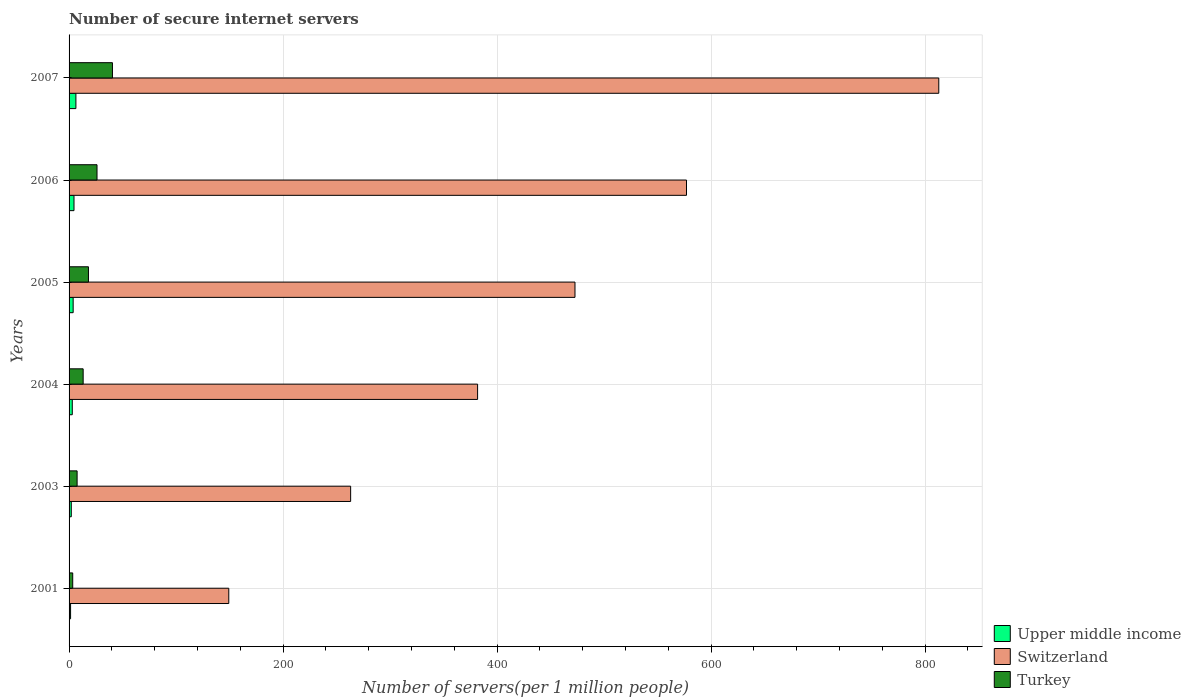How many different coloured bars are there?
Make the answer very short. 3. Are the number of bars per tick equal to the number of legend labels?
Your answer should be compact. Yes. What is the label of the 5th group of bars from the top?
Provide a short and direct response. 2003. In how many cases, is the number of bars for a given year not equal to the number of legend labels?
Provide a short and direct response. 0. What is the number of secure internet servers in Switzerland in 2007?
Offer a terse response. 812.73. Across all years, what is the maximum number of secure internet servers in Turkey?
Ensure brevity in your answer.  40.54. Across all years, what is the minimum number of secure internet servers in Switzerland?
Keep it short and to the point. 149.24. What is the total number of secure internet servers in Upper middle income in the graph?
Your answer should be compact. 21.26. What is the difference between the number of secure internet servers in Switzerland in 2005 and that in 2007?
Make the answer very short. -339.96. What is the difference between the number of secure internet servers in Switzerland in 2004 and the number of secure internet servers in Turkey in 2007?
Provide a succinct answer. 341.21. What is the average number of secure internet servers in Upper middle income per year?
Provide a succinct answer. 3.54. In the year 2006, what is the difference between the number of secure internet servers in Turkey and number of secure internet servers in Switzerland?
Offer a very short reply. -550.86. What is the ratio of the number of secure internet servers in Turkey in 2006 to that in 2007?
Your answer should be very brief. 0.64. What is the difference between the highest and the second highest number of secure internet servers in Turkey?
Provide a short and direct response. 14.43. What is the difference between the highest and the lowest number of secure internet servers in Upper middle income?
Your response must be concise. 4.97. What does the 3rd bar from the top in 2005 represents?
Offer a very short reply. Upper middle income. What does the 3rd bar from the bottom in 2005 represents?
Ensure brevity in your answer.  Turkey. How many bars are there?
Provide a succinct answer. 18. What is the difference between two consecutive major ticks on the X-axis?
Ensure brevity in your answer.  200. Are the values on the major ticks of X-axis written in scientific E-notation?
Keep it short and to the point. No. Does the graph contain grids?
Offer a very short reply. Yes. Where does the legend appear in the graph?
Ensure brevity in your answer.  Bottom right. What is the title of the graph?
Keep it short and to the point. Number of secure internet servers. What is the label or title of the X-axis?
Offer a very short reply. Number of servers(per 1 million people). What is the label or title of the Y-axis?
Provide a short and direct response. Years. What is the Number of servers(per 1 million people) of Upper middle income in 2001?
Your answer should be very brief. 1.41. What is the Number of servers(per 1 million people) of Switzerland in 2001?
Provide a succinct answer. 149.24. What is the Number of servers(per 1 million people) in Turkey in 2001?
Keep it short and to the point. 3.41. What is the Number of servers(per 1 million people) of Upper middle income in 2003?
Give a very brief answer. 2.06. What is the Number of servers(per 1 million people) in Switzerland in 2003?
Give a very brief answer. 263.11. What is the Number of servers(per 1 million people) of Turkey in 2003?
Offer a terse response. 7.51. What is the Number of servers(per 1 million people) of Upper middle income in 2004?
Your answer should be compact. 3. What is the Number of servers(per 1 million people) in Switzerland in 2004?
Give a very brief answer. 381.75. What is the Number of servers(per 1 million people) in Turkey in 2004?
Offer a terse response. 13.17. What is the Number of servers(per 1 million people) in Upper middle income in 2005?
Offer a very short reply. 3.82. What is the Number of servers(per 1 million people) in Switzerland in 2005?
Your answer should be compact. 472.76. What is the Number of servers(per 1 million people) of Turkey in 2005?
Your answer should be very brief. 18.11. What is the Number of servers(per 1 million people) in Upper middle income in 2006?
Ensure brevity in your answer.  4.6. What is the Number of servers(per 1 million people) in Switzerland in 2006?
Your answer should be compact. 576.97. What is the Number of servers(per 1 million people) of Turkey in 2006?
Make the answer very short. 26.11. What is the Number of servers(per 1 million people) in Upper middle income in 2007?
Provide a short and direct response. 6.38. What is the Number of servers(per 1 million people) of Switzerland in 2007?
Provide a succinct answer. 812.73. What is the Number of servers(per 1 million people) in Turkey in 2007?
Offer a very short reply. 40.54. Across all years, what is the maximum Number of servers(per 1 million people) of Upper middle income?
Offer a terse response. 6.38. Across all years, what is the maximum Number of servers(per 1 million people) of Switzerland?
Your response must be concise. 812.73. Across all years, what is the maximum Number of servers(per 1 million people) in Turkey?
Offer a terse response. 40.54. Across all years, what is the minimum Number of servers(per 1 million people) in Upper middle income?
Give a very brief answer. 1.41. Across all years, what is the minimum Number of servers(per 1 million people) in Switzerland?
Offer a very short reply. 149.24. Across all years, what is the minimum Number of servers(per 1 million people) in Turkey?
Your response must be concise. 3.41. What is the total Number of servers(per 1 million people) in Upper middle income in the graph?
Provide a short and direct response. 21.26. What is the total Number of servers(per 1 million people) in Switzerland in the graph?
Provide a succinct answer. 2656.57. What is the total Number of servers(per 1 million people) in Turkey in the graph?
Keep it short and to the point. 108.85. What is the difference between the Number of servers(per 1 million people) of Upper middle income in 2001 and that in 2003?
Make the answer very short. -0.65. What is the difference between the Number of servers(per 1 million people) of Switzerland in 2001 and that in 2003?
Your answer should be very brief. -113.87. What is the difference between the Number of servers(per 1 million people) in Turkey in 2001 and that in 2003?
Keep it short and to the point. -4.1. What is the difference between the Number of servers(per 1 million people) of Upper middle income in 2001 and that in 2004?
Make the answer very short. -1.59. What is the difference between the Number of servers(per 1 million people) in Switzerland in 2001 and that in 2004?
Your answer should be very brief. -232.51. What is the difference between the Number of servers(per 1 million people) in Turkey in 2001 and that in 2004?
Ensure brevity in your answer.  -9.76. What is the difference between the Number of servers(per 1 million people) of Upper middle income in 2001 and that in 2005?
Offer a terse response. -2.41. What is the difference between the Number of servers(per 1 million people) of Switzerland in 2001 and that in 2005?
Offer a terse response. -323.52. What is the difference between the Number of servers(per 1 million people) of Turkey in 2001 and that in 2005?
Your answer should be compact. -14.7. What is the difference between the Number of servers(per 1 million people) of Upper middle income in 2001 and that in 2006?
Your answer should be very brief. -3.19. What is the difference between the Number of servers(per 1 million people) in Switzerland in 2001 and that in 2006?
Give a very brief answer. -427.73. What is the difference between the Number of servers(per 1 million people) of Turkey in 2001 and that in 2006?
Your answer should be very brief. -22.7. What is the difference between the Number of servers(per 1 million people) of Upper middle income in 2001 and that in 2007?
Offer a very short reply. -4.97. What is the difference between the Number of servers(per 1 million people) of Switzerland in 2001 and that in 2007?
Your answer should be very brief. -663.49. What is the difference between the Number of servers(per 1 million people) of Turkey in 2001 and that in 2007?
Your response must be concise. -37.13. What is the difference between the Number of servers(per 1 million people) of Upper middle income in 2003 and that in 2004?
Give a very brief answer. -0.94. What is the difference between the Number of servers(per 1 million people) in Switzerland in 2003 and that in 2004?
Provide a short and direct response. -118.64. What is the difference between the Number of servers(per 1 million people) of Turkey in 2003 and that in 2004?
Your response must be concise. -5.66. What is the difference between the Number of servers(per 1 million people) in Upper middle income in 2003 and that in 2005?
Offer a terse response. -1.75. What is the difference between the Number of servers(per 1 million people) in Switzerland in 2003 and that in 2005?
Keep it short and to the point. -209.65. What is the difference between the Number of servers(per 1 million people) in Turkey in 2003 and that in 2005?
Your answer should be very brief. -10.6. What is the difference between the Number of servers(per 1 million people) in Upper middle income in 2003 and that in 2006?
Your response must be concise. -2.54. What is the difference between the Number of servers(per 1 million people) of Switzerland in 2003 and that in 2006?
Give a very brief answer. -313.85. What is the difference between the Number of servers(per 1 million people) of Turkey in 2003 and that in 2006?
Offer a very short reply. -18.6. What is the difference between the Number of servers(per 1 million people) of Upper middle income in 2003 and that in 2007?
Your response must be concise. -4.32. What is the difference between the Number of servers(per 1 million people) of Switzerland in 2003 and that in 2007?
Offer a very short reply. -549.61. What is the difference between the Number of servers(per 1 million people) in Turkey in 2003 and that in 2007?
Make the answer very short. -33.03. What is the difference between the Number of servers(per 1 million people) of Upper middle income in 2004 and that in 2005?
Ensure brevity in your answer.  -0.82. What is the difference between the Number of servers(per 1 million people) in Switzerland in 2004 and that in 2005?
Offer a very short reply. -91.01. What is the difference between the Number of servers(per 1 million people) of Turkey in 2004 and that in 2005?
Provide a succinct answer. -4.94. What is the difference between the Number of servers(per 1 million people) of Upper middle income in 2004 and that in 2006?
Make the answer very short. -1.6. What is the difference between the Number of servers(per 1 million people) of Switzerland in 2004 and that in 2006?
Provide a short and direct response. -195.22. What is the difference between the Number of servers(per 1 million people) in Turkey in 2004 and that in 2006?
Give a very brief answer. -12.94. What is the difference between the Number of servers(per 1 million people) of Upper middle income in 2004 and that in 2007?
Ensure brevity in your answer.  -3.38. What is the difference between the Number of servers(per 1 million people) of Switzerland in 2004 and that in 2007?
Provide a short and direct response. -430.98. What is the difference between the Number of servers(per 1 million people) of Turkey in 2004 and that in 2007?
Provide a succinct answer. -27.37. What is the difference between the Number of servers(per 1 million people) in Upper middle income in 2005 and that in 2006?
Offer a terse response. -0.78. What is the difference between the Number of servers(per 1 million people) of Switzerland in 2005 and that in 2006?
Offer a terse response. -104.21. What is the difference between the Number of servers(per 1 million people) in Turkey in 2005 and that in 2006?
Provide a short and direct response. -8. What is the difference between the Number of servers(per 1 million people) in Upper middle income in 2005 and that in 2007?
Make the answer very short. -2.57. What is the difference between the Number of servers(per 1 million people) of Switzerland in 2005 and that in 2007?
Your response must be concise. -339.96. What is the difference between the Number of servers(per 1 million people) of Turkey in 2005 and that in 2007?
Give a very brief answer. -22.43. What is the difference between the Number of servers(per 1 million people) of Upper middle income in 2006 and that in 2007?
Make the answer very short. -1.78. What is the difference between the Number of servers(per 1 million people) of Switzerland in 2006 and that in 2007?
Make the answer very short. -235.76. What is the difference between the Number of servers(per 1 million people) of Turkey in 2006 and that in 2007?
Provide a short and direct response. -14.43. What is the difference between the Number of servers(per 1 million people) of Upper middle income in 2001 and the Number of servers(per 1 million people) of Switzerland in 2003?
Your answer should be compact. -261.71. What is the difference between the Number of servers(per 1 million people) in Upper middle income in 2001 and the Number of servers(per 1 million people) in Turkey in 2003?
Provide a succinct answer. -6.1. What is the difference between the Number of servers(per 1 million people) in Switzerland in 2001 and the Number of servers(per 1 million people) in Turkey in 2003?
Ensure brevity in your answer.  141.73. What is the difference between the Number of servers(per 1 million people) in Upper middle income in 2001 and the Number of servers(per 1 million people) in Switzerland in 2004?
Offer a terse response. -380.34. What is the difference between the Number of servers(per 1 million people) of Upper middle income in 2001 and the Number of servers(per 1 million people) of Turkey in 2004?
Make the answer very short. -11.76. What is the difference between the Number of servers(per 1 million people) of Switzerland in 2001 and the Number of servers(per 1 million people) of Turkey in 2004?
Your answer should be very brief. 136.07. What is the difference between the Number of servers(per 1 million people) of Upper middle income in 2001 and the Number of servers(per 1 million people) of Switzerland in 2005?
Your answer should be compact. -471.35. What is the difference between the Number of servers(per 1 million people) of Upper middle income in 2001 and the Number of servers(per 1 million people) of Turkey in 2005?
Give a very brief answer. -16.7. What is the difference between the Number of servers(per 1 million people) in Switzerland in 2001 and the Number of servers(per 1 million people) in Turkey in 2005?
Offer a terse response. 131.13. What is the difference between the Number of servers(per 1 million people) of Upper middle income in 2001 and the Number of servers(per 1 million people) of Switzerland in 2006?
Your answer should be very brief. -575.56. What is the difference between the Number of servers(per 1 million people) in Upper middle income in 2001 and the Number of servers(per 1 million people) in Turkey in 2006?
Provide a short and direct response. -24.7. What is the difference between the Number of servers(per 1 million people) of Switzerland in 2001 and the Number of servers(per 1 million people) of Turkey in 2006?
Your answer should be compact. 123.13. What is the difference between the Number of servers(per 1 million people) in Upper middle income in 2001 and the Number of servers(per 1 million people) in Switzerland in 2007?
Give a very brief answer. -811.32. What is the difference between the Number of servers(per 1 million people) of Upper middle income in 2001 and the Number of servers(per 1 million people) of Turkey in 2007?
Keep it short and to the point. -39.13. What is the difference between the Number of servers(per 1 million people) in Switzerland in 2001 and the Number of servers(per 1 million people) in Turkey in 2007?
Provide a succinct answer. 108.7. What is the difference between the Number of servers(per 1 million people) of Upper middle income in 2003 and the Number of servers(per 1 million people) of Switzerland in 2004?
Make the answer very short. -379.69. What is the difference between the Number of servers(per 1 million people) in Upper middle income in 2003 and the Number of servers(per 1 million people) in Turkey in 2004?
Your answer should be very brief. -11.11. What is the difference between the Number of servers(per 1 million people) in Switzerland in 2003 and the Number of servers(per 1 million people) in Turkey in 2004?
Your answer should be very brief. 249.95. What is the difference between the Number of servers(per 1 million people) in Upper middle income in 2003 and the Number of servers(per 1 million people) in Switzerland in 2005?
Give a very brief answer. -470.7. What is the difference between the Number of servers(per 1 million people) in Upper middle income in 2003 and the Number of servers(per 1 million people) in Turkey in 2005?
Give a very brief answer. -16.05. What is the difference between the Number of servers(per 1 million people) of Switzerland in 2003 and the Number of servers(per 1 million people) of Turkey in 2005?
Keep it short and to the point. 245. What is the difference between the Number of servers(per 1 million people) of Upper middle income in 2003 and the Number of servers(per 1 million people) of Switzerland in 2006?
Make the answer very short. -574.91. What is the difference between the Number of servers(per 1 million people) in Upper middle income in 2003 and the Number of servers(per 1 million people) in Turkey in 2006?
Your answer should be compact. -24.05. What is the difference between the Number of servers(per 1 million people) of Switzerland in 2003 and the Number of servers(per 1 million people) of Turkey in 2006?
Give a very brief answer. 237. What is the difference between the Number of servers(per 1 million people) in Upper middle income in 2003 and the Number of servers(per 1 million people) in Switzerland in 2007?
Provide a succinct answer. -810.67. What is the difference between the Number of servers(per 1 million people) of Upper middle income in 2003 and the Number of servers(per 1 million people) of Turkey in 2007?
Your answer should be compact. -38.48. What is the difference between the Number of servers(per 1 million people) of Switzerland in 2003 and the Number of servers(per 1 million people) of Turkey in 2007?
Offer a very short reply. 222.58. What is the difference between the Number of servers(per 1 million people) in Upper middle income in 2004 and the Number of servers(per 1 million people) in Switzerland in 2005?
Ensure brevity in your answer.  -469.77. What is the difference between the Number of servers(per 1 million people) of Upper middle income in 2004 and the Number of servers(per 1 million people) of Turkey in 2005?
Offer a terse response. -15.11. What is the difference between the Number of servers(per 1 million people) in Switzerland in 2004 and the Number of servers(per 1 million people) in Turkey in 2005?
Your response must be concise. 363.64. What is the difference between the Number of servers(per 1 million people) in Upper middle income in 2004 and the Number of servers(per 1 million people) in Switzerland in 2006?
Provide a succinct answer. -573.97. What is the difference between the Number of servers(per 1 million people) in Upper middle income in 2004 and the Number of servers(per 1 million people) in Turkey in 2006?
Give a very brief answer. -23.12. What is the difference between the Number of servers(per 1 million people) of Switzerland in 2004 and the Number of servers(per 1 million people) of Turkey in 2006?
Provide a short and direct response. 355.64. What is the difference between the Number of servers(per 1 million people) of Upper middle income in 2004 and the Number of servers(per 1 million people) of Switzerland in 2007?
Your response must be concise. -809.73. What is the difference between the Number of servers(per 1 million people) in Upper middle income in 2004 and the Number of servers(per 1 million people) in Turkey in 2007?
Keep it short and to the point. -37.54. What is the difference between the Number of servers(per 1 million people) in Switzerland in 2004 and the Number of servers(per 1 million people) in Turkey in 2007?
Keep it short and to the point. 341.21. What is the difference between the Number of servers(per 1 million people) in Upper middle income in 2005 and the Number of servers(per 1 million people) in Switzerland in 2006?
Ensure brevity in your answer.  -573.15. What is the difference between the Number of servers(per 1 million people) of Upper middle income in 2005 and the Number of servers(per 1 million people) of Turkey in 2006?
Your answer should be very brief. -22.3. What is the difference between the Number of servers(per 1 million people) of Switzerland in 2005 and the Number of servers(per 1 million people) of Turkey in 2006?
Your response must be concise. 446.65. What is the difference between the Number of servers(per 1 million people) in Upper middle income in 2005 and the Number of servers(per 1 million people) in Switzerland in 2007?
Provide a succinct answer. -808.91. What is the difference between the Number of servers(per 1 million people) in Upper middle income in 2005 and the Number of servers(per 1 million people) in Turkey in 2007?
Keep it short and to the point. -36.72. What is the difference between the Number of servers(per 1 million people) in Switzerland in 2005 and the Number of servers(per 1 million people) in Turkey in 2007?
Offer a terse response. 432.23. What is the difference between the Number of servers(per 1 million people) of Upper middle income in 2006 and the Number of servers(per 1 million people) of Switzerland in 2007?
Your response must be concise. -808.13. What is the difference between the Number of servers(per 1 million people) in Upper middle income in 2006 and the Number of servers(per 1 million people) in Turkey in 2007?
Provide a short and direct response. -35.94. What is the difference between the Number of servers(per 1 million people) in Switzerland in 2006 and the Number of servers(per 1 million people) in Turkey in 2007?
Provide a succinct answer. 536.43. What is the average Number of servers(per 1 million people) of Upper middle income per year?
Keep it short and to the point. 3.54. What is the average Number of servers(per 1 million people) in Switzerland per year?
Offer a terse response. 442.76. What is the average Number of servers(per 1 million people) of Turkey per year?
Keep it short and to the point. 18.14. In the year 2001, what is the difference between the Number of servers(per 1 million people) in Upper middle income and Number of servers(per 1 million people) in Switzerland?
Your answer should be compact. -147.83. In the year 2001, what is the difference between the Number of servers(per 1 million people) in Upper middle income and Number of servers(per 1 million people) in Turkey?
Your answer should be compact. -2. In the year 2001, what is the difference between the Number of servers(per 1 million people) of Switzerland and Number of servers(per 1 million people) of Turkey?
Make the answer very short. 145.83. In the year 2003, what is the difference between the Number of servers(per 1 million people) in Upper middle income and Number of servers(per 1 million people) in Switzerland?
Provide a short and direct response. -261.05. In the year 2003, what is the difference between the Number of servers(per 1 million people) of Upper middle income and Number of servers(per 1 million people) of Turkey?
Ensure brevity in your answer.  -5.45. In the year 2003, what is the difference between the Number of servers(per 1 million people) of Switzerland and Number of servers(per 1 million people) of Turkey?
Keep it short and to the point. 255.61. In the year 2004, what is the difference between the Number of servers(per 1 million people) of Upper middle income and Number of servers(per 1 million people) of Switzerland?
Your answer should be compact. -378.76. In the year 2004, what is the difference between the Number of servers(per 1 million people) of Upper middle income and Number of servers(per 1 million people) of Turkey?
Offer a terse response. -10.17. In the year 2004, what is the difference between the Number of servers(per 1 million people) in Switzerland and Number of servers(per 1 million people) in Turkey?
Offer a terse response. 368.58. In the year 2005, what is the difference between the Number of servers(per 1 million people) of Upper middle income and Number of servers(per 1 million people) of Switzerland?
Offer a terse response. -468.95. In the year 2005, what is the difference between the Number of servers(per 1 million people) of Upper middle income and Number of servers(per 1 million people) of Turkey?
Your answer should be compact. -14.29. In the year 2005, what is the difference between the Number of servers(per 1 million people) of Switzerland and Number of servers(per 1 million people) of Turkey?
Make the answer very short. 454.65. In the year 2006, what is the difference between the Number of servers(per 1 million people) of Upper middle income and Number of servers(per 1 million people) of Switzerland?
Make the answer very short. -572.37. In the year 2006, what is the difference between the Number of servers(per 1 million people) in Upper middle income and Number of servers(per 1 million people) in Turkey?
Offer a terse response. -21.51. In the year 2006, what is the difference between the Number of servers(per 1 million people) of Switzerland and Number of servers(per 1 million people) of Turkey?
Make the answer very short. 550.86. In the year 2007, what is the difference between the Number of servers(per 1 million people) of Upper middle income and Number of servers(per 1 million people) of Switzerland?
Your answer should be very brief. -806.35. In the year 2007, what is the difference between the Number of servers(per 1 million people) in Upper middle income and Number of servers(per 1 million people) in Turkey?
Ensure brevity in your answer.  -34.16. In the year 2007, what is the difference between the Number of servers(per 1 million people) in Switzerland and Number of servers(per 1 million people) in Turkey?
Make the answer very short. 772.19. What is the ratio of the Number of servers(per 1 million people) in Upper middle income in 2001 to that in 2003?
Give a very brief answer. 0.68. What is the ratio of the Number of servers(per 1 million people) in Switzerland in 2001 to that in 2003?
Your response must be concise. 0.57. What is the ratio of the Number of servers(per 1 million people) in Turkey in 2001 to that in 2003?
Offer a very short reply. 0.45. What is the ratio of the Number of servers(per 1 million people) in Upper middle income in 2001 to that in 2004?
Offer a very short reply. 0.47. What is the ratio of the Number of servers(per 1 million people) in Switzerland in 2001 to that in 2004?
Ensure brevity in your answer.  0.39. What is the ratio of the Number of servers(per 1 million people) in Turkey in 2001 to that in 2004?
Your answer should be compact. 0.26. What is the ratio of the Number of servers(per 1 million people) in Upper middle income in 2001 to that in 2005?
Provide a succinct answer. 0.37. What is the ratio of the Number of servers(per 1 million people) of Switzerland in 2001 to that in 2005?
Ensure brevity in your answer.  0.32. What is the ratio of the Number of servers(per 1 million people) in Turkey in 2001 to that in 2005?
Ensure brevity in your answer.  0.19. What is the ratio of the Number of servers(per 1 million people) of Upper middle income in 2001 to that in 2006?
Make the answer very short. 0.31. What is the ratio of the Number of servers(per 1 million people) of Switzerland in 2001 to that in 2006?
Make the answer very short. 0.26. What is the ratio of the Number of servers(per 1 million people) of Turkey in 2001 to that in 2006?
Offer a terse response. 0.13. What is the ratio of the Number of servers(per 1 million people) in Upper middle income in 2001 to that in 2007?
Give a very brief answer. 0.22. What is the ratio of the Number of servers(per 1 million people) in Switzerland in 2001 to that in 2007?
Your answer should be very brief. 0.18. What is the ratio of the Number of servers(per 1 million people) of Turkey in 2001 to that in 2007?
Offer a very short reply. 0.08. What is the ratio of the Number of servers(per 1 million people) of Upper middle income in 2003 to that in 2004?
Ensure brevity in your answer.  0.69. What is the ratio of the Number of servers(per 1 million people) in Switzerland in 2003 to that in 2004?
Make the answer very short. 0.69. What is the ratio of the Number of servers(per 1 million people) in Turkey in 2003 to that in 2004?
Give a very brief answer. 0.57. What is the ratio of the Number of servers(per 1 million people) in Upper middle income in 2003 to that in 2005?
Your response must be concise. 0.54. What is the ratio of the Number of servers(per 1 million people) in Switzerland in 2003 to that in 2005?
Offer a terse response. 0.56. What is the ratio of the Number of servers(per 1 million people) in Turkey in 2003 to that in 2005?
Your response must be concise. 0.41. What is the ratio of the Number of servers(per 1 million people) of Upper middle income in 2003 to that in 2006?
Your answer should be compact. 0.45. What is the ratio of the Number of servers(per 1 million people) in Switzerland in 2003 to that in 2006?
Ensure brevity in your answer.  0.46. What is the ratio of the Number of servers(per 1 million people) of Turkey in 2003 to that in 2006?
Ensure brevity in your answer.  0.29. What is the ratio of the Number of servers(per 1 million people) of Upper middle income in 2003 to that in 2007?
Make the answer very short. 0.32. What is the ratio of the Number of servers(per 1 million people) in Switzerland in 2003 to that in 2007?
Your answer should be compact. 0.32. What is the ratio of the Number of servers(per 1 million people) of Turkey in 2003 to that in 2007?
Your answer should be very brief. 0.19. What is the ratio of the Number of servers(per 1 million people) of Upper middle income in 2004 to that in 2005?
Your response must be concise. 0.79. What is the ratio of the Number of servers(per 1 million people) in Switzerland in 2004 to that in 2005?
Your response must be concise. 0.81. What is the ratio of the Number of servers(per 1 million people) in Turkey in 2004 to that in 2005?
Give a very brief answer. 0.73. What is the ratio of the Number of servers(per 1 million people) in Upper middle income in 2004 to that in 2006?
Your answer should be compact. 0.65. What is the ratio of the Number of servers(per 1 million people) of Switzerland in 2004 to that in 2006?
Offer a terse response. 0.66. What is the ratio of the Number of servers(per 1 million people) in Turkey in 2004 to that in 2006?
Your answer should be very brief. 0.5. What is the ratio of the Number of servers(per 1 million people) in Upper middle income in 2004 to that in 2007?
Make the answer very short. 0.47. What is the ratio of the Number of servers(per 1 million people) of Switzerland in 2004 to that in 2007?
Your response must be concise. 0.47. What is the ratio of the Number of servers(per 1 million people) of Turkey in 2004 to that in 2007?
Offer a very short reply. 0.32. What is the ratio of the Number of servers(per 1 million people) in Upper middle income in 2005 to that in 2006?
Your response must be concise. 0.83. What is the ratio of the Number of servers(per 1 million people) of Switzerland in 2005 to that in 2006?
Keep it short and to the point. 0.82. What is the ratio of the Number of servers(per 1 million people) in Turkey in 2005 to that in 2006?
Your answer should be compact. 0.69. What is the ratio of the Number of servers(per 1 million people) in Upper middle income in 2005 to that in 2007?
Make the answer very short. 0.6. What is the ratio of the Number of servers(per 1 million people) of Switzerland in 2005 to that in 2007?
Give a very brief answer. 0.58. What is the ratio of the Number of servers(per 1 million people) in Turkey in 2005 to that in 2007?
Provide a short and direct response. 0.45. What is the ratio of the Number of servers(per 1 million people) in Upper middle income in 2006 to that in 2007?
Make the answer very short. 0.72. What is the ratio of the Number of servers(per 1 million people) in Switzerland in 2006 to that in 2007?
Ensure brevity in your answer.  0.71. What is the ratio of the Number of servers(per 1 million people) in Turkey in 2006 to that in 2007?
Your response must be concise. 0.64. What is the difference between the highest and the second highest Number of servers(per 1 million people) in Upper middle income?
Provide a succinct answer. 1.78. What is the difference between the highest and the second highest Number of servers(per 1 million people) of Switzerland?
Keep it short and to the point. 235.76. What is the difference between the highest and the second highest Number of servers(per 1 million people) in Turkey?
Make the answer very short. 14.43. What is the difference between the highest and the lowest Number of servers(per 1 million people) in Upper middle income?
Ensure brevity in your answer.  4.97. What is the difference between the highest and the lowest Number of servers(per 1 million people) in Switzerland?
Keep it short and to the point. 663.49. What is the difference between the highest and the lowest Number of servers(per 1 million people) in Turkey?
Offer a terse response. 37.13. 